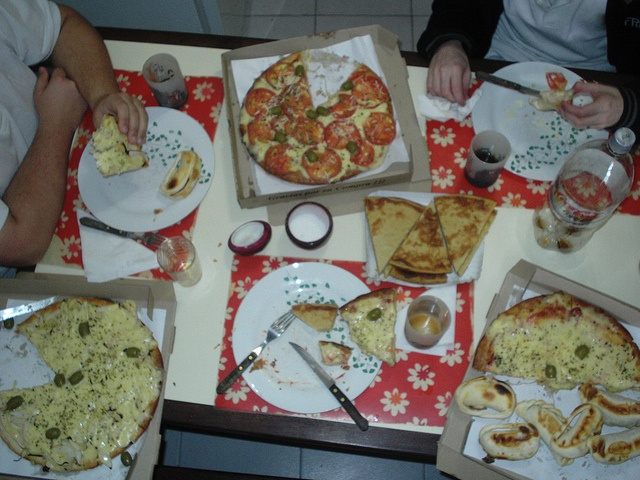Describe the objects in this image and their specific colors. I can see dining table in darkgray, gray, and olive tones, pizza in gray, olive, and darkgreen tones, people in purple, gray, maroon, and black tones, people in gray, black, and blue tones, and pizza in gray, maroon, olive, and brown tones in this image. 